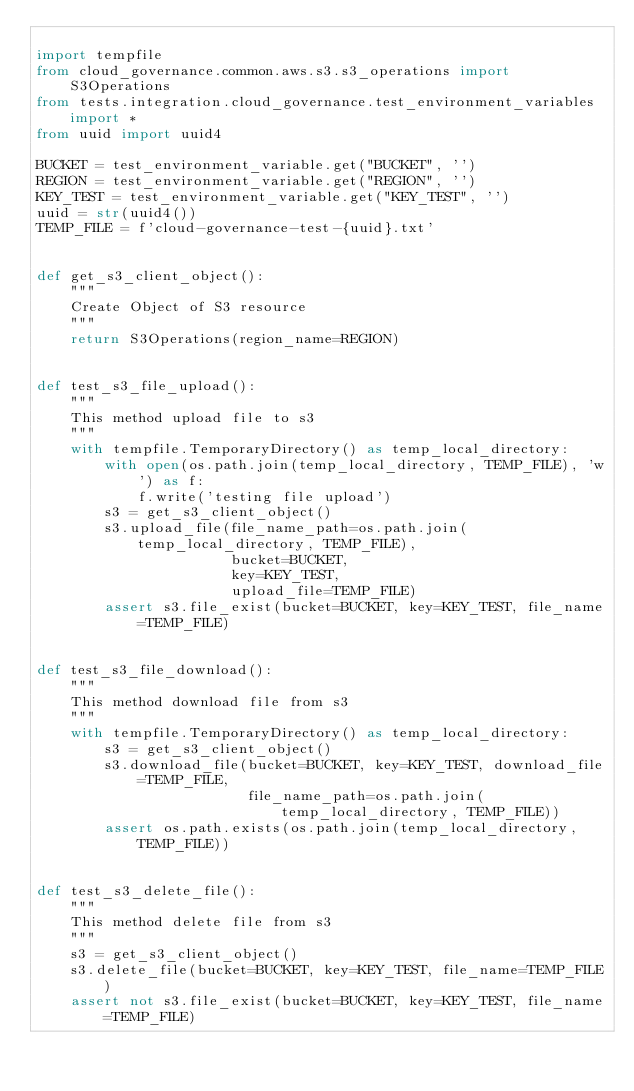Convert code to text. <code><loc_0><loc_0><loc_500><loc_500><_Python_>
import tempfile
from cloud_governance.common.aws.s3.s3_operations import S3Operations
from tests.integration.cloud_governance.test_environment_variables import *
from uuid import uuid4

BUCKET = test_environment_variable.get("BUCKET", '')
REGION = test_environment_variable.get("REGION", '')
KEY_TEST = test_environment_variable.get("KEY_TEST", '')
uuid = str(uuid4())
TEMP_FILE = f'cloud-governance-test-{uuid}.txt'


def get_s3_client_object():
    """
    Create Object of S3 resource
    """
    return S3Operations(region_name=REGION)


def test_s3_file_upload():
    """
    This method upload file to s3
    """
    with tempfile.TemporaryDirectory() as temp_local_directory:
        with open(os.path.join(temp_local_directory, TEMP_FILE), 'w') as f:
            f.write('testing file upload')
        s3 = get_s3_client_object()
        s3.upload_file(file_name_path=os.path.join(temp_local_directory, TEMP_FILE),
                       bucket=BUCKET,
                       key=KEY_TEST,
                       upload_file=TEMP_FILE)
        assert s3.file_exist(bucket=BUCKET, key=KEY_TEST, file_name=TEMP_FILE)


def test_s3_file_download():
    """
    This method download file from s3
    """
    with tempfile.TemporaryDirectory() as temp_local_directory:
        s3 = get_s3_client_object()
        s3.download_file(bucket=BUCKET, key=KEY_TEST, download_file=TEMP_FILE,
                         file_name_path=os.path.join(temp_local_directory, TEMP_FILE))
        assert os.path.exists(os.path.join(temp_local_directory, TEMP_FILE))


def test_s3_delete_file():
    """
    This method delete file from s3
    """
    s3 = get_s3_client_object()
    s3.delete_file(bucket=BUCKET, key=KEY_TEST, file_name=TEMP_FILE)
    assert not s3.file_exist(bucket=BUCKET, key=KEY_TEST, file_name=TEMP_FILE)
</code> 